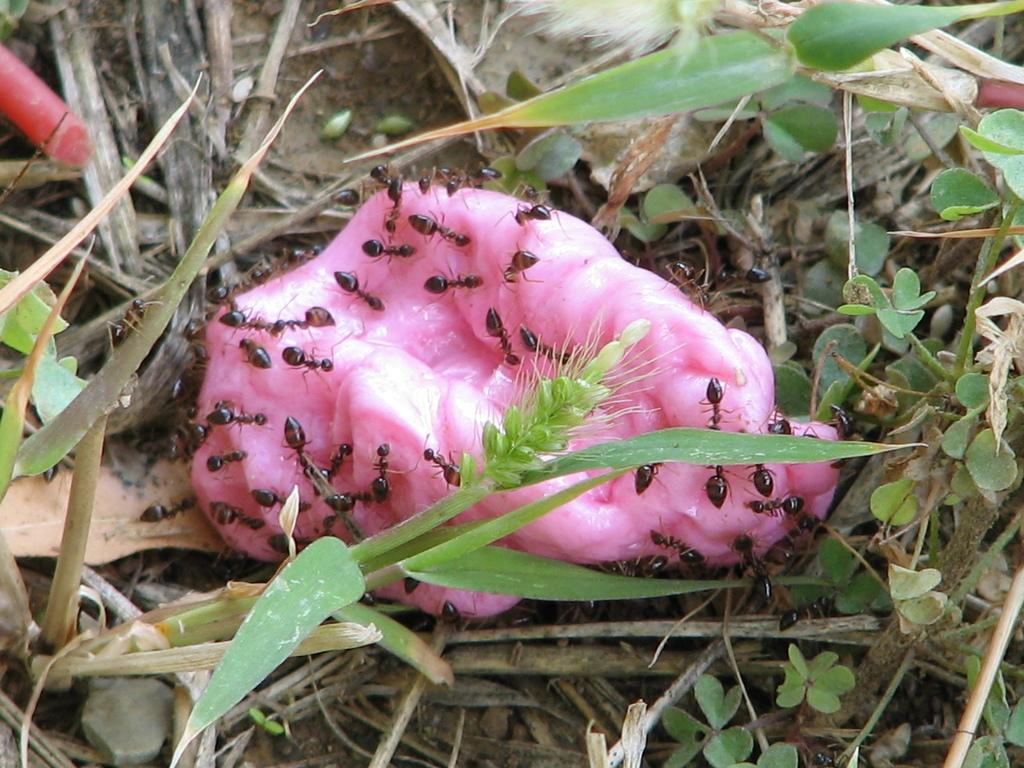What is the color of the object that has ants on it? The object has a pink color. Can you describe the ants in the image? The ants are on the pink object. What type of vegetation is present in the image? There are green color leaves in the image. What type of noise can be heard coming from the letter in the image? There is no letter present in the image, so it is not possible to determine what, if any, noise might be heard. 